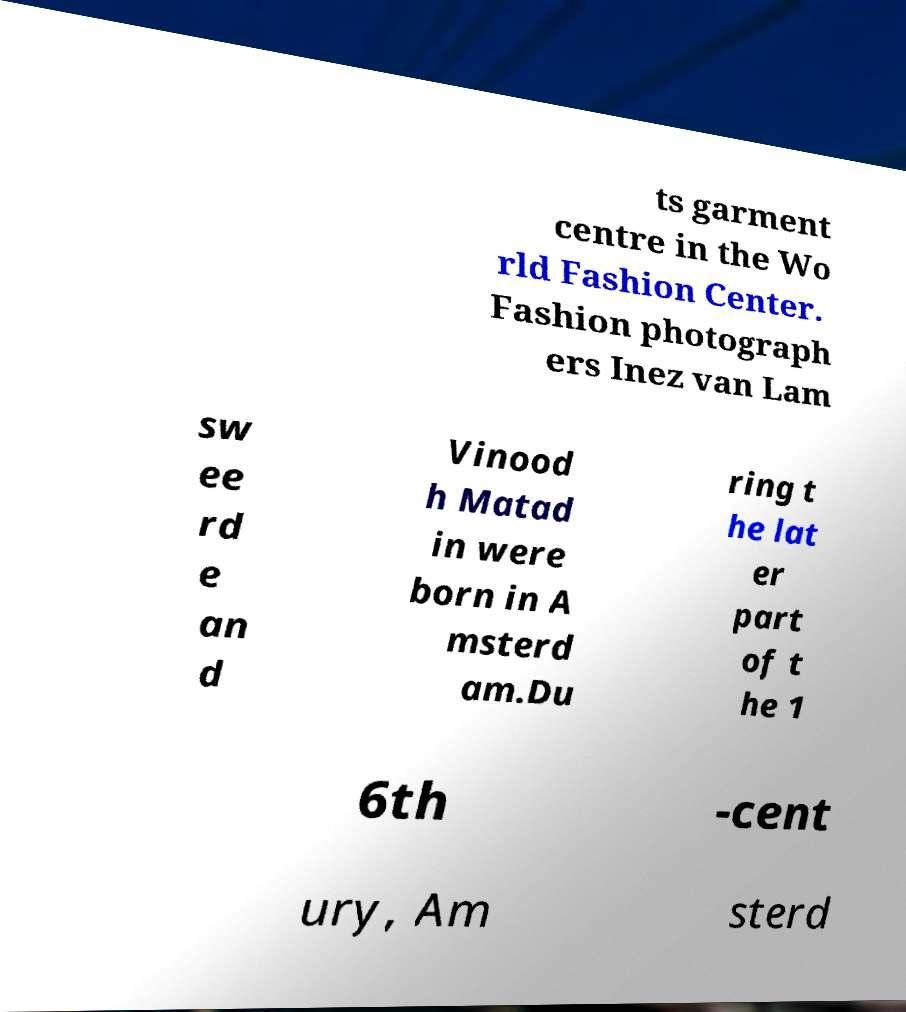Please read and relay the text visible in this image. What does it say? ts garment centre in the Wo rld Fashion Center. Fashion photograph ers Inez van Lam sw ee rd e an d Vinood h Matad in were born in A msterd am.Du ring t he lat er part of t he 1 6th -cent ury, Am sterd 